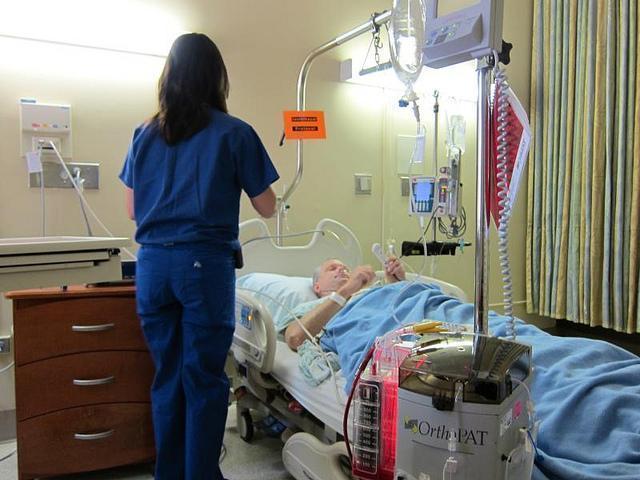Where is the man laying?
Make your selection from the four choices given to correctly answer the question.
Options: Couch, beach, floor, hospital bed. Hospital bed. 